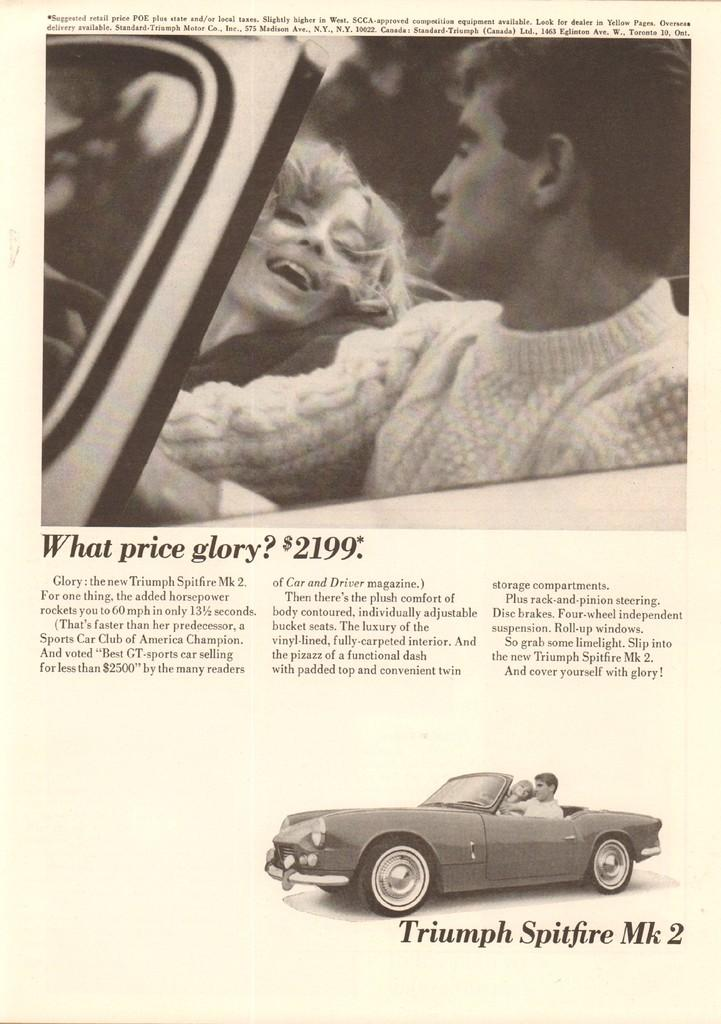What is present on the paper in the image? There is a paper in the image. What can be found on the paper besides the paper itself? There are words, numbers, and images on the paper. What type of donkey is depicted wearing a shirt in the image? There is no donkey or shirt present in the image; the image only features a paper with words, numbers, and images on it. 